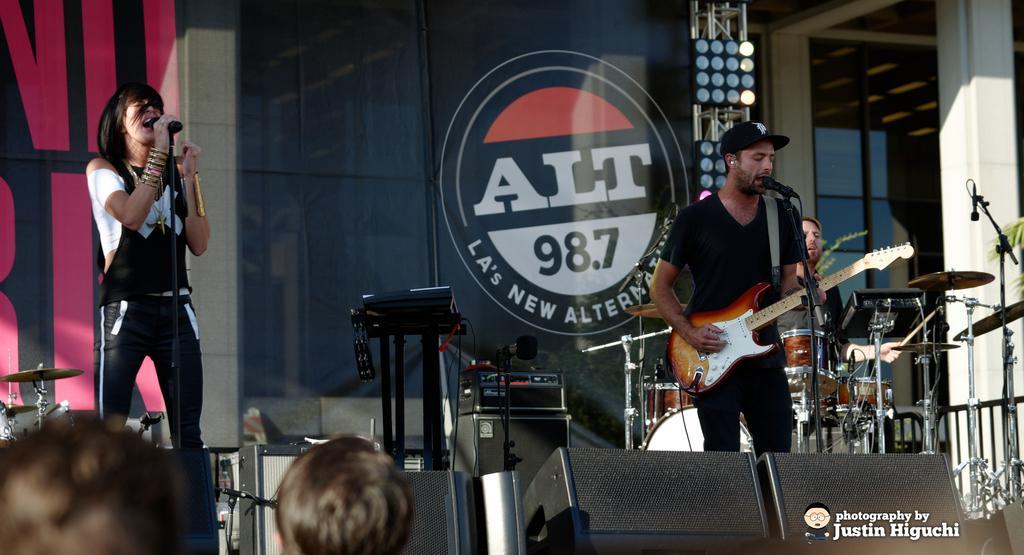Could you give a brief overview of what you see in this image? Here is a woman singing a song using a mike. And I can see a man standing,playing guitar and singing a song. At background I can see another person sitting and playing drums. I think these are the speakers which are black in color. At background can see a poster. And I think these are some other objects placed on it. This looks like a stage performance. This is a pillar and this is a glass door. These are the audience watching the performance. 